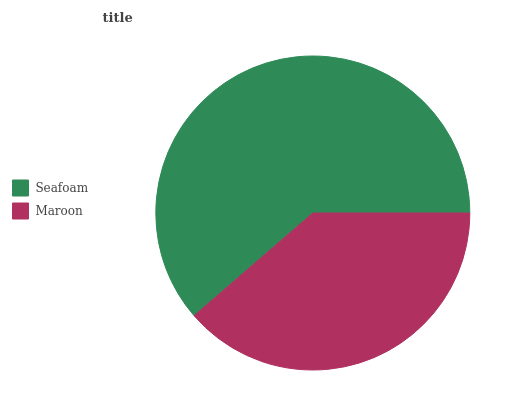Is Maroon the minimum?
Answer yes or no. Yes. Is Seafoam the maximum?
Answer yes or no. Yes. Is Maroon the maximum?
Answer yes or no. No. Is Seafoam greater than Maroon?
Answer yes or no. Yes. Is Maroon less than Seafoam?
Answer yes or no. Yes. Is Maroon greater than Seafoam?
Answer yes or no. No. Is Seafoam less than Maroon?
Answer yes or no. No. Is Seafoam the high median?
Answer yes or no. Yes. Is Maroon the low median?
Answer yes or no. Yes. Is Maroon the high median?
Answer yes or no. No. Is Seafoam the low median?
Answer yes or no. No. 